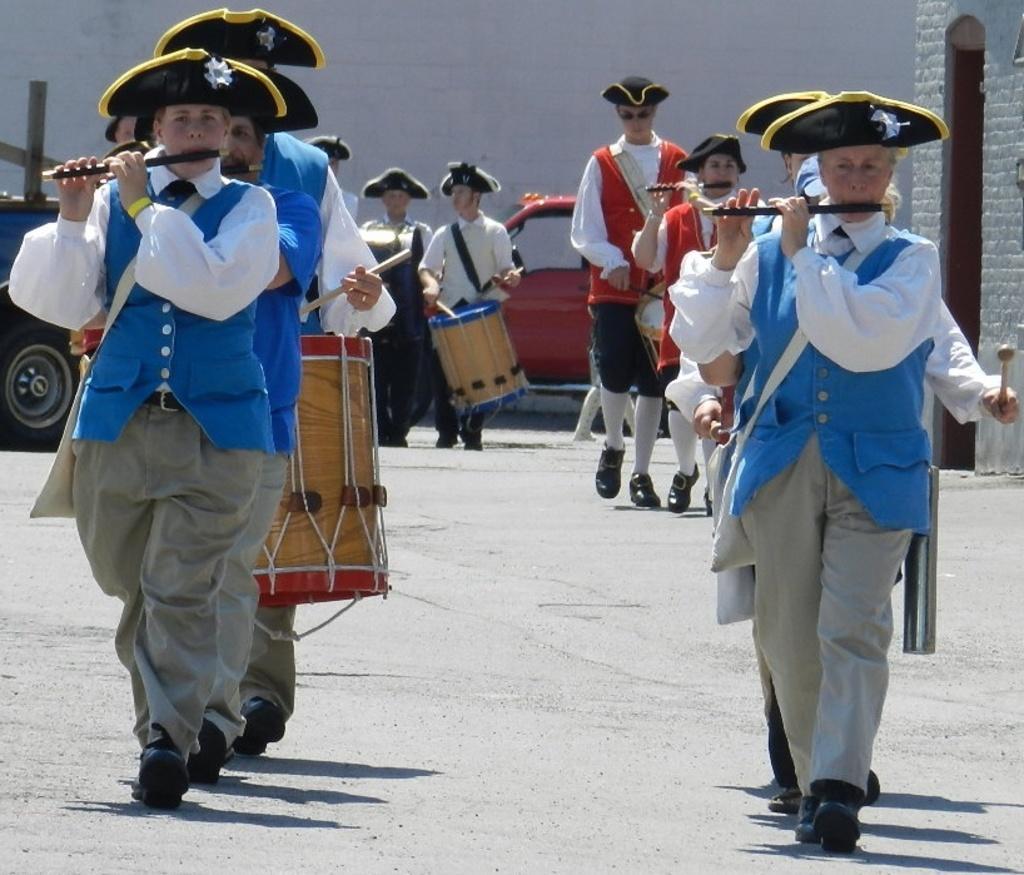Could you give a brief overview of what you see in this image? In the image wee can see there are people who are standing on the road and in front people are holding flute and drums and at the back car parked on the road. 